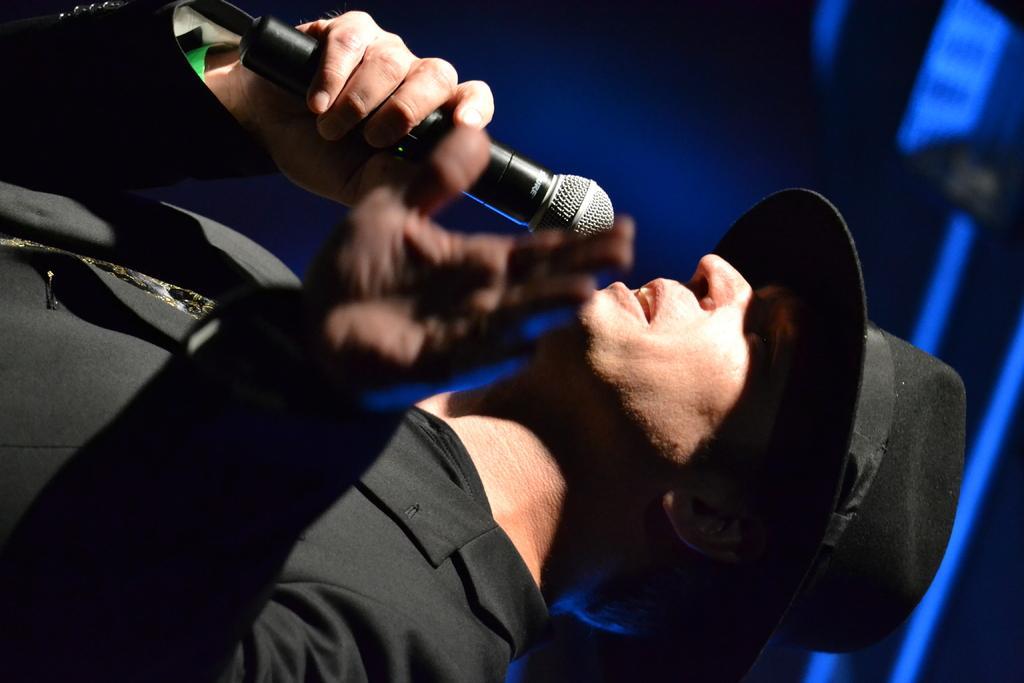Could you give a brief overview of what you see in this image? In this image we can see a person wearing a dress and hat is holding a microphone in his hand. In the background, we can see some lights. 